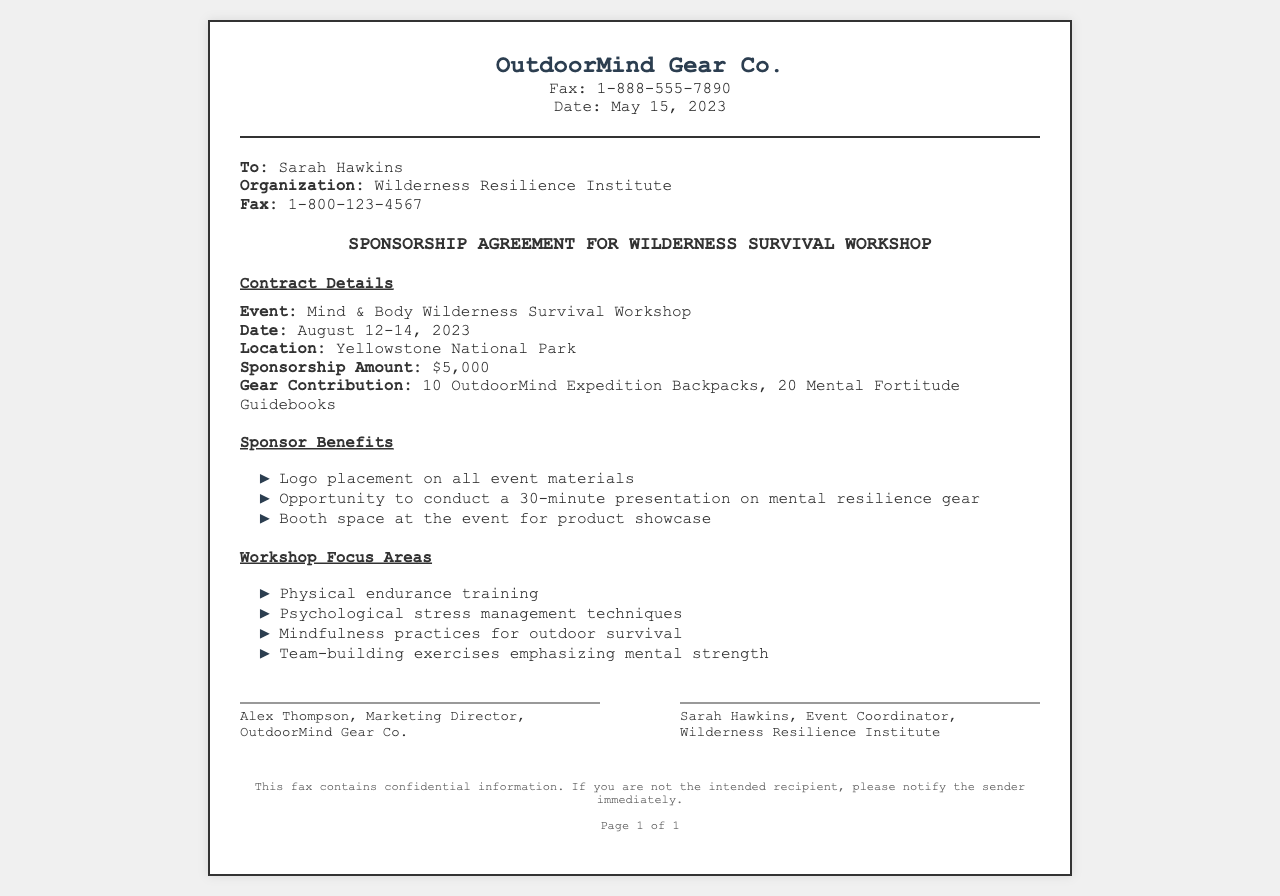What is the name of the workshop? The name of the workshop is mentioned in the contract details section.
Answer: Mind & Body Wilderness Survival Workshop What are the dates of the event? The dates of the event are specified under the contract details section.
Answer: August 12-14, 2023 How much is the sponsorship amount? The sponsorship amount is listed in the contract details section.
Answer: $5,000 What gear is OutdoorMind contributing? The gear contribution is specified in the contract details section.
Answer: 10 OutdoorMind Expedition Backpacks, 20 Mental Fortitude Guidebooks Who is the event coordinator? The event coordinator's name is listed in the signatures section.
Answer: Sarah Hawkins What is one focus area of the workshop? One focus area is mentioned in the workshop focus areas section; any of them can be used for the answer.
Answer: Psychological stress management techniques What opportunity does the sponsor have at the event? The opportunity for the sponsor is highlighted in the sponsor benefits section.
Answer: Conduct a 30-minute presentation on mental resilience gear What is the location of the workshop? The location is given in the contract details section.
Answer: Yellowstone National Park What does the footer indicate about the fax? The footer contains a note about confidentiality.
Answer: Confidential information 